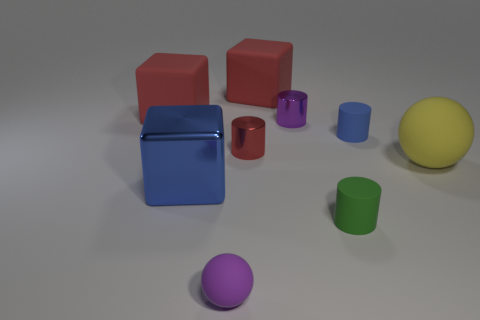Are there any things behind the small rubber ball?
Make the answer very short. Yes. Is there anything else that has the same color as the shiny block?
Keep it short and to the point. Yes. How many blocks are big red matte things or small green rubber objects?
Offer a terse response. 2. How many objects are both in front of the large rubber ball and behind the tiny green cylinder?
Provide a succinct answer. 1. Is the number of big yellow spheres in front of the small purple rubber object the same as the number of rubber things on the right side of the large blue block?
Ensure brevity in your answer.  No. There is a tiny thing that is behind the small blue thing; is it the same shape as the large yellow matte thing?
Your response must be concise. No. What is the shape of the large red rubber object that is to the left of the block that is in front of the big sphere that is behind the large blue metal cube?
Your answer should be very brief. Cube. What shape is the shiny object that is the same color as the tiny ball?
Your answer should be compact. Cylinder. The large object that is in front of the purple cylinder and on the left side of the big yellow matte thing is made of what material?
Your answer should be compact. Metal. Is the number of red objects less than the number of large purple objects?
Your answer should be compact. No. 